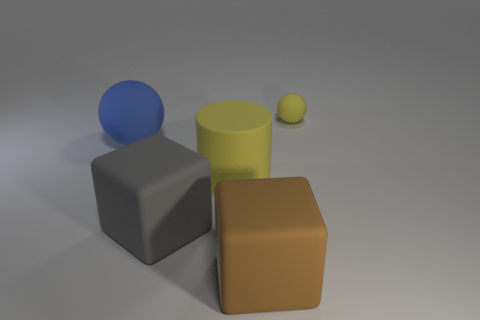Add 4 tiny blue metal cylinders. How many objects exist? 9 Subtract all balls. How many objects are left? 3 Add 2 gray rubber things. How many gray rubber things are left? 3 Add 2 gray matte things. How many gray matte things exist? 3 Subtract 0 cyan cylinders. How many objects are left? 5 Subtract all matte cubes. Subtract all blue matte things. How many objects are left? 2 